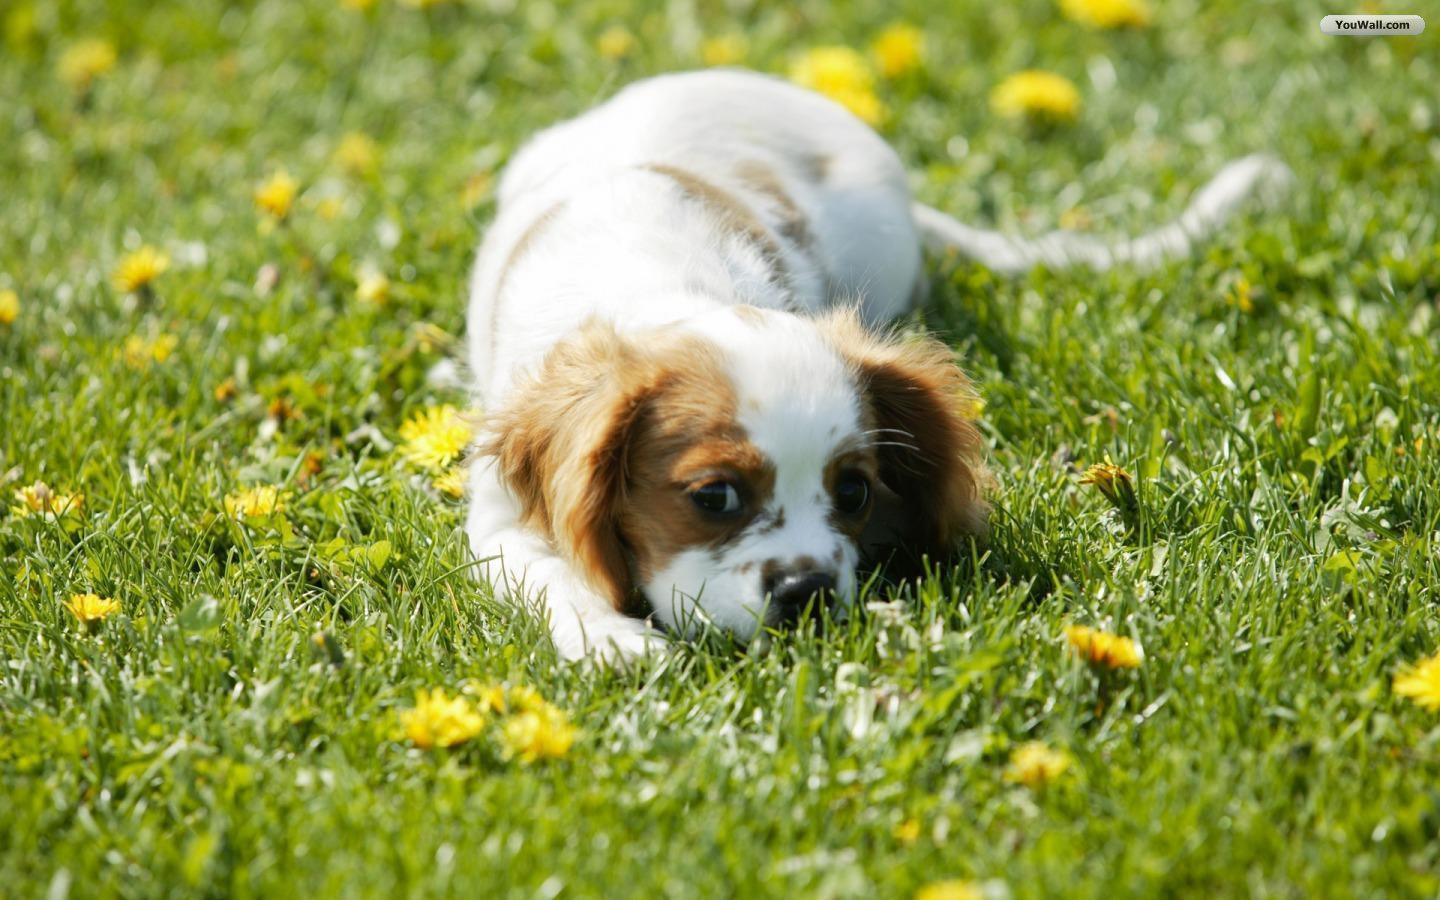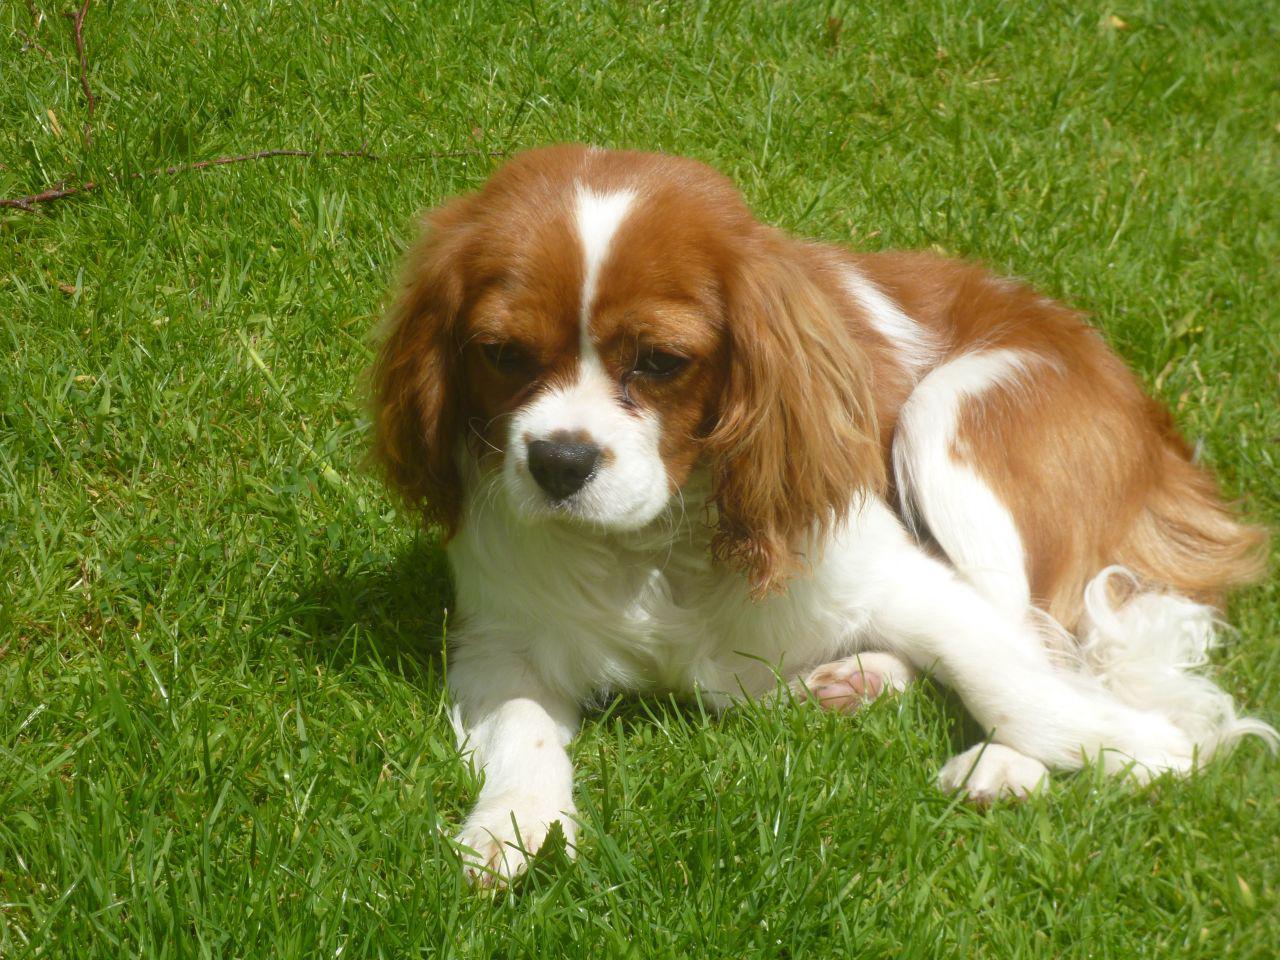The first image is the image on the left, the second image is the image on the right. For the images displayed, is the sentence "At least one image has no grass." factually correct? Answer yes or no. No. 